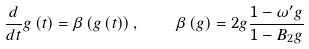Convert formula to latex. <formula><loc_0><loc_0><loc_500><loc_500>\frac { d } { d t } g \left ( t \right ) = \beta \left ( g \left ( t \right ) \right ) , \quad \beta \left ( g \right ) = 2 g \frac { 1 - \omega ^ { \prime } g } { 1 - B _ { 2 } g }</formula> 